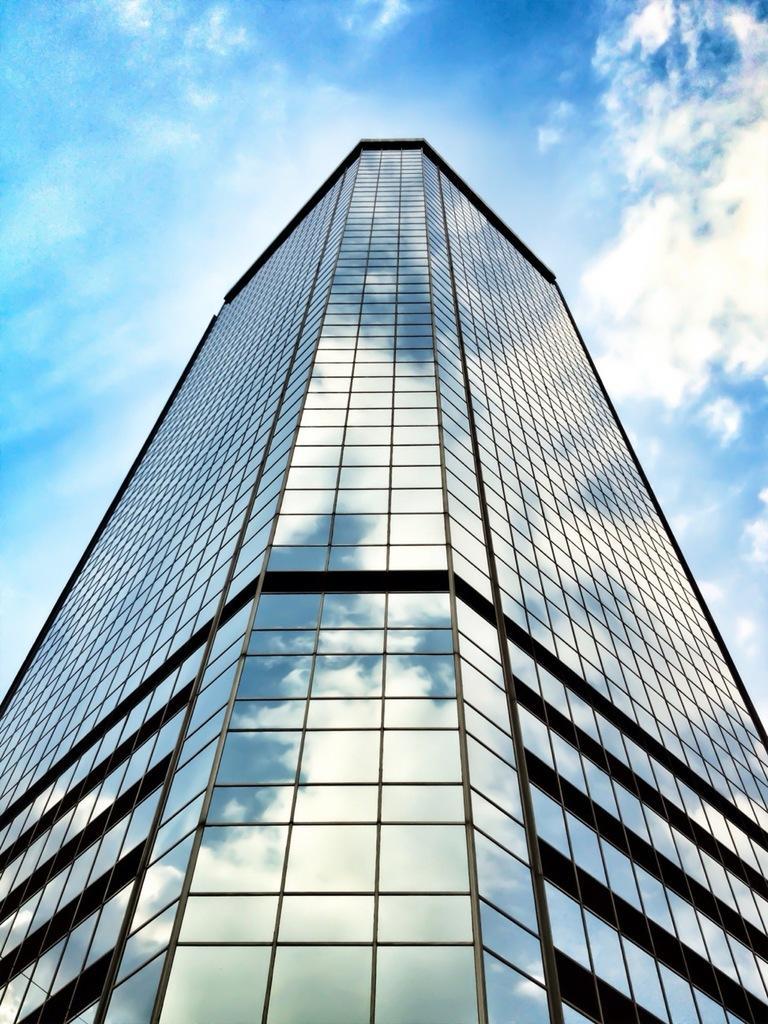Please provide a concise description of this image. In this image I can see a glass building, background the sky is in blue and white color. 